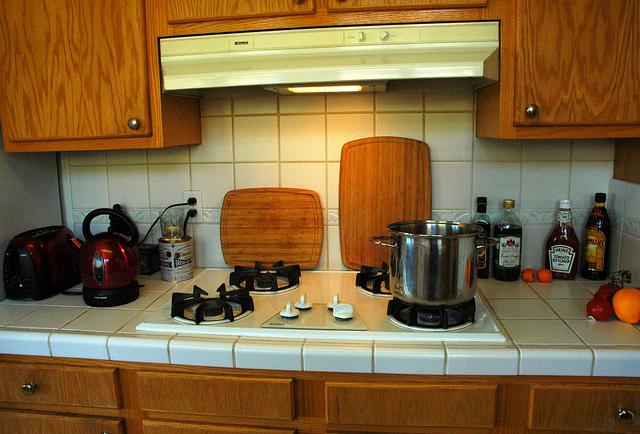What is on the stove?
Answer briefly. Pot. What color are the knobs?
Keep it brief. Silver. What brand of ketchup is on the counter?
Answer briefly. Heinz. What kind of appliance is on the counter?
Be succinct. Toaster. 